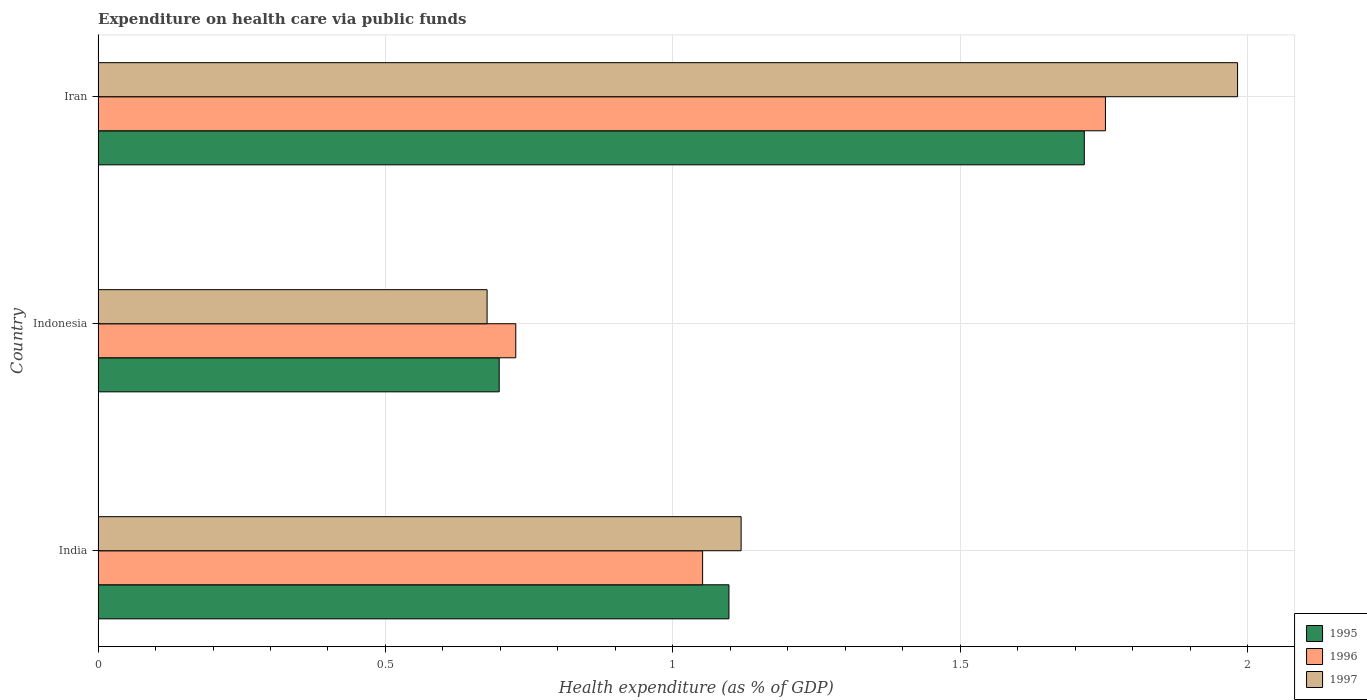How many different coloured bars are there?
Make the answer very short. 3. Are the number of bars on each tick of the Y-axis equal?
Provide a short and direct response. Yes. How many bars are there on the 1st tick from the top?
Give a very brief answer. 3. In how many cases, is the number of bars for a given country not equal to the number of legend labels?
Make the answer very short. 0. What is the expenditure made on health care in 1996 in Iran?
Offer a very short reply. 1.75. Across all countries, what is the maximum expenditure made on health care in 1996?
Offer a very short reply. 1.75. Across all countries, what is the minimum expenditure made on health care in 1997?
Your answer should be compact. 0.68. In which country was the expenditure made on health care in 1996 maximum?
Your response must be concise. Iran. In which country was the expenditure made on health care in 1997 minimum?
Give a very brief answer. Indonesia. What is the total expenditure made on health care in 1997 in the graph?
Ensure brevity in your answer.  3.78. What is the difference between the expenditure made on health care in 1997 in India and that in Indonesia?
Your answer should be compact. 0.44. What is the difference between the expenditure made on health care in 1995 in India and the expenditure made on health care in 1997 in Iran?
Your answer should be compact. -0.89. What is the average expenditure made on health care in 1995 per country?
Your answer should be very brief. 1.17. What is the difference between the expenditure made on health care in 1995 and expenditure made on health care in 1997 in Indonesia?
Your response must be concise. 0.02. What is the ratio of the expenditure made on health care in 1997 in India to that in Indonesia?
Your answer should be very brief. 1.65. Is the expenditure made on health care in 1997 in India less than that in Iran?
Make the answer very short. Yes. Is the difference between the expenditure made on health care in 1995 in Indonesia and Iran greater than the difference between the expenditure made on health care in 1997 in Indonesia and Iran?
Offer a terse response. Yes. What is the difference between the highest and the second highest expenditure made on health care in 1996?
Offer a very short reply. 0.7. What is the difference between the highest and the lowest expenditure made on health care in 1996?
Offer a very short reply. 1.03. How many bars are there?
Provide a succinct answer. 9. Are all the bars in the graph horizontal?
Give a very brief answer. Yes. How many countries are there in the graph?
Make the answer very short. 3. What is the difference between two consecutive major ticks on the X-axis?
Provide a succinct answer. 0.5. Are the values on the major ticks of X-axis written in scientific E-notation?
Ensure brevity in your answer.  No. Where does the legend appear in the graph?
Provide a succinct answer. Bottom right. How many legend labels are there?
Provide a succinct answer. 3. What is the title of the graph?
Offer a very short reply. Expenditure on health care via public funds. What is the label or title of the X-axis?
Your response must be concise. Health expenditure (as % of GDP). What is the Health expenditure (as % of GDP) of 1995 in India?
Offer a terse response. 1.1. What is the Health expenditure (as % of GDP) of 1996 in India?
Provide a short and direct response. 1.05. What is the Health expenditure (as % of GDP) of 1997 in India?
Provide a succinct answer. 1.12. What is the Health expenditure (as % of GDP) of 1995 in Indonesia?
Your answer should be compact. 0.7. What is the Health expenditure (as % of GDP) of 1996 in Indonesia?
Give a very brief answer. 0.73. What is the Health expenditure (as % of GDP) in 1997 in Indonesia?
Your answer should be very brief. 0.68. What is the Health expenditure (as % of GDP) in 1995 in Iran?
Give a very brief answer. 1.72. What is the Health expenditure (as % of GDP) of 1996 in Iran?
Make the answer very short. 1.75. What is the Health expenditure (as % of GDP) in 1997 in Iran?
Give a very brief answer. 1.98. Across all countries, what is the maximum Health expenditure (as % of GDP) in 1995?
Provide a succinct answer. 1.72. Across all countries, what is the maximum Health expenditure (as % of GDP) in 1996?
Keep it short and to the point. 1.75. Across all countries, what is the maximum Health expenditure (as % of GDP) of 1997?
Give a very brief answer. 1.98. Across all countries, what is the minimum Health expenditure (as % of GDP) of 1995?
Offer a terse response. 0.7. Across all countries, what is the minimum Health expenditure (as % of GDP) in 1996?
Offer a very short reply. 0.73. Across all countries, what is the minimum Health expenditure (as % of GDP) in 1997?
Your answer should be compact. 0.68. What is the total Health expenditure (as % of GDP) in 1995 in the graph?
Make the answer very short. 3.51. What is the total Health expenditure (as % of GDP) in 1996 in the graph?
Provide a short and direct response. 3.53. What is the total Health expenditure (as % of GDP) in 1997 in the graph?
Keep it short and to the point. 3.78. What is the difference between the Health expenditure (as % of GDP) in 1995 in India and that in Indonesia?
Keep it short and to the point. 0.4. What is the difference between the Health expenditure (as % of GDP) in 1996 in India and that in Indonesia?
Your answer should be compact. 0.33. What is the difference between the Health expenditure (as % of GDP) in 1997 in India and that in Indonesia?
Provide a short and direct response. 0.44. What is the difference between the Health expenditure (as % of GDP) in 1995 in India and that in Iran?
Provide a short and direct response. -0.62. What is the difference between the Health expenditure (as % of GDP) in 1996 in India and that in Iran?
Give a very brief answer. -0.7. What is the difference between the Health expenditure (as % of GDP) of 1997 in India and that in Iran?
Keep it short and to the point. -0.86. What is the difference between the Health expenditure (as % of GDP) of 1995 in Indonesia and that in Iran?
Ensure brevity in your answer.  -1.02. What is the difference between the Health expenditure (as % of GDP) of 1996 in Indonesia and that in Iran?
Give a very brief answer. -1.03. What is the difference between the Health expenditure (as % of GDP) of 1997 in Indonesia and that in Iran?
Offer a very short reply. -1.31. What is the difference between the Health expenditure (as % of GDP) of 1995 in India and the Health expenditure (as % of GDP) of 1996 in Indonesia?
Ensure brevity in your answer.  0.37. What is the difference between the Health expenditure (as % of GDP) in 1995 in India and the Health expenditure (as % of GDP) in 1997 in Indonesia?
Make the answer very short. 0.42. What is the difference between the Health expenditure (as % of GDP) of 1995 in India and the Health expenditure (as % of GDP) of 1996 in Iran?
Provide a succinct answer. -0.66. What is the difference between the Health expenditure (as % of GDP) in 1995 in India and the Health expenditure (as % of GDP) in 1997 in Iran?
Ensure brevity in your answer.  -0.89. What is the difference between the Health expenditure (as % of GDP) of 1996 in India and the Health expenditure (as % of GDP) of 1997 in Iran?
Your answer should be very brief. -0.93. What is the difference between the Health expenditure (as % of GDP) of 1995 in Indonesia and the Health expenditure (as % of GDP) of 1996 in Iran?
Provide a short and direct response. -1.05. What is the difference between the Health expenditure (as % of GDP) in 1995 in Indonesia and the Health expenditure (as % of GDP) in 1997 in Iran?
Ensure brevity in your answer.  -1.28. What is the difference between the Health expenditure (as % of GDP) of 1996 in Indonesia and the Health expenditure (as % of GDP) of 1997 in Iran?
Keep it short and to the point. -1.26. What is the average Health expenditure (as % of GDP) of 1995 per country?
Make the answer very short. 1.17. What is the average Health expenditure (as % of GDP) in 1996 per country?
Keep it short and to the point. 1.18. What is the average Health expenditure (as % of GDP) in 1997 per country?
Keep it short and to the point. 1.26. What is the difference between the Health expenditure (as % of GDP) of 1995 and Health expenditure (as % of GDP) of 1996 in India?
Your answer should be very brief. 0.05. What is the difference between the Health expenditure (as % of GDP) in 1995 and Health expenditure (as % of GDP) in 1997 in India?
Offer a terse response. -0.02. What is the difference between the Health expenditure (as % of GDP) of 1996 and Health expenditure (as % of GDP) of 1997 in India?
Your response must be concise. -0.07. What is the difference between the Health expenditure (as % of GDP) in 1995 and Health expenditure (as % of GDP) in 1996 in Indonesia?
Give a very brief answer. -0.03. What is the difference between the Health expenditure (as % of GDP) in 1995 and Health expenditure (as % of GDP) in 1997 in Indonesia?
Offer a very short reply. 0.02. What is the difference between the Health expenditure (as % of GDP) of 1996 and Health expenditure (as % of GDP) of 1997 in Indonesia?
Your answer should be very brief. 0.05. What is the difference between the Health expenditure (as % of GDP) of 1995 and Health expenditure (as % of GDP) of 1996 in Iran?
Your answer should be very brief. -0.04. What is the difference between the Health expenditure (as % of GDP) of 1995 and Health expenditure (as % of GDP) of 1997 in Iran?
Offer a very short reply. -0.27. What is the difference between the Health expenditure (as % of GDP) in 1996 and Health expenditure (as % of GDP) in 1997 in Iran?
Ensure brevity in your answer.  -0.23. What is the ratio of the Health expenditure (as % of GDP) in 1995 in India to that in Indonesia?
Offer a terse response. 1.57. What is the ratio of the Health expenditure (as % of GDP) in 1996 in India to that in Indonesia?
Keep it short and to the point. 1.45. What is the ratio of the Health expenditure (as % of GDP) of 1997 in India to that in Indonesia?
Make the answer very short. 1.65. What is the ratio of the Health expenditure (as % of GDP) of 1995 in India to that in Iran?
Your response must be concise. 0.64. What is the ratio of the Health expenditure (as % of GDP) of 1996 in India to that in Iran?
Ensure brevity in your answer.  0.6. What is the ratio of the Health expenditure (as % of GDP) in 1997 in India to that in Iran?
Your response must be concise. 0.56. What is the ratio of the Health expenditure (as % of GDP) of 1995 in Indonesia to that in Iran?
Offer a very short reply. 0.41. What is the ratio of the Health expenditure (as % of GDP) of 1996 in Indonesia to that in Iran?
Your answer should be very brief. 0.41. What is the ratio of the Health expenditure (as % of GDP) in 1997 in Indonesia to that in Iran?
Offer a terse response. 0.34. What is the difference between the highest and the second highest Health expenditure (as % of GDP) in 1995?
Provide a succinct answer. 0.62. What is the difference between the highest and the second highest Health expenditure (as % of GDP) of 1996?
Provide a short and direct response. 0.7. What is the difference between the highest and the second highest Health expenditure (as % of GDP) of 1997?
Ensure brevity in your answer.  0.86. What is the difference between the highest and the lowest Health expenditure (as % of GDP) of 1995?
Your answer should be compact. 1.02. What is the difference between the highest and the lowest Health expenditure (as % of GDP) in 1996?
Your answer should be compact. 1.03. What is the difference between the highest and the lowest Health expenditure (as % of GDP) of 1997?
Your answer should be compact. 1.31. 